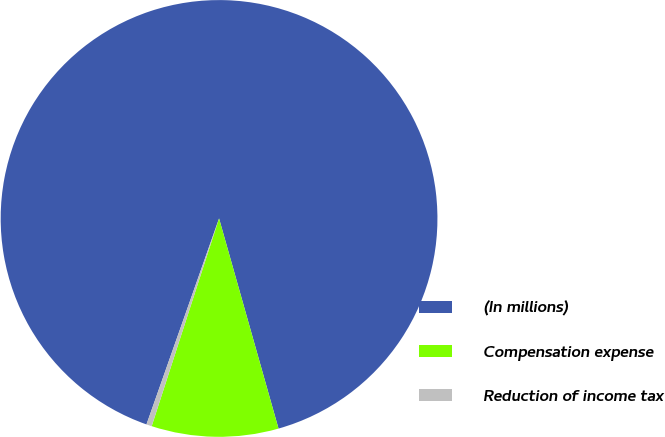Convert chart. <chart><loc_0><loc_0><loc_500><loc_500><pie_chart><fcel>(In millions)<fcel>Compensation expense<fcel>Reduction of income tax<nl><fcel>90.21%<fcel>9.38%<fcel>0.4%<nl></chart> 